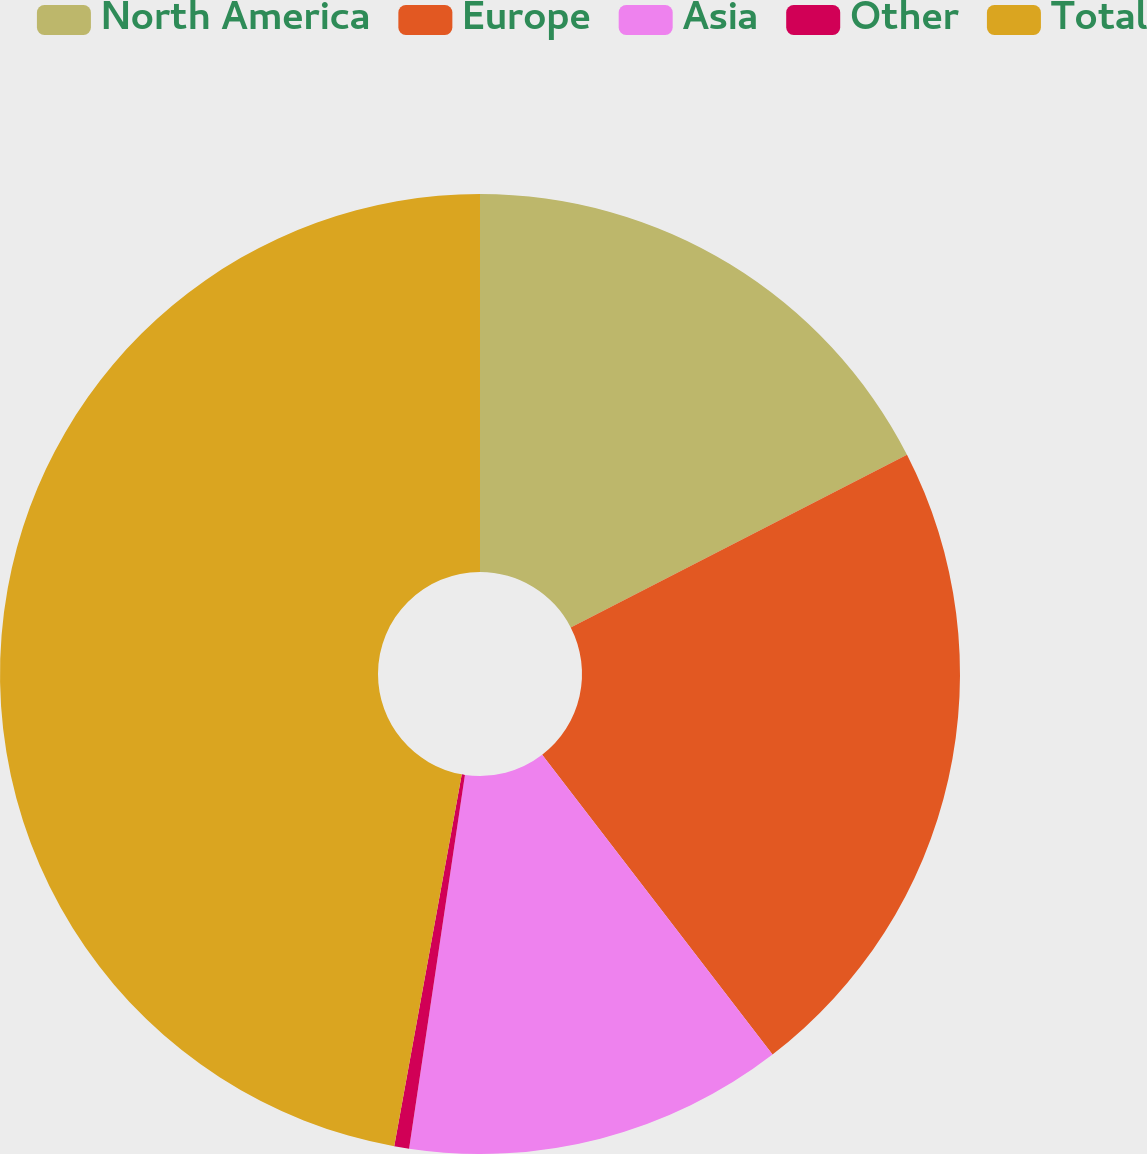<chart> <loc_0><loc_0><loc_500><loc_500><pie_chart><fcel>North America<fcel>Europe<fcel>Asia<fcel>Other<fcel>Total<nl><fcel>17.45%<fcel>22.12%<fcel>12.79%<fcel>0.5%<fcel>47.14%<nl></chart> 